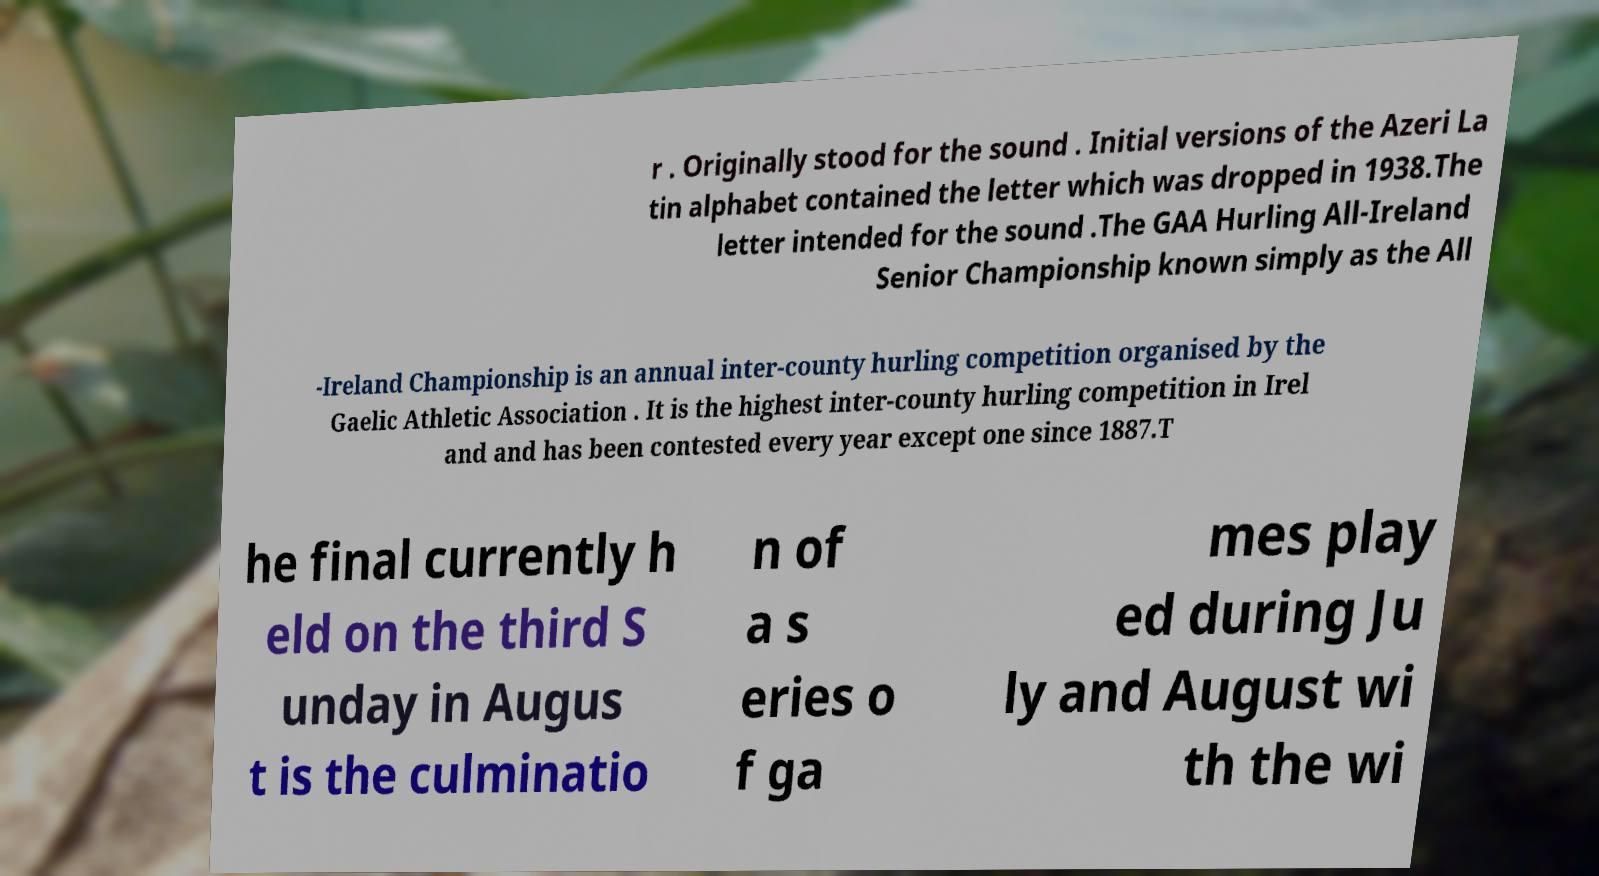For documentation purposes, I need the text within this image transcribed. Could you provide that? r . Originally stood for the sound . Initial versions of the Azeri La tin alphabet contained the letter which was dropped in 1938.The letter intended for the sound .The GAA Hurling All-Ireland Senior Championship known simply as the All -Ireland Championship is an annual inter-county hurling competition organised by the Gaelic Athletic Association . It is the highest inter-county hurling competition in Irel and and has been contested every year except one since 1887.T he final currently h eld on the third S unday in Augus t is the culminatio n of a s eries o f ga mes play ed during Ju ly and August wi th the wi 